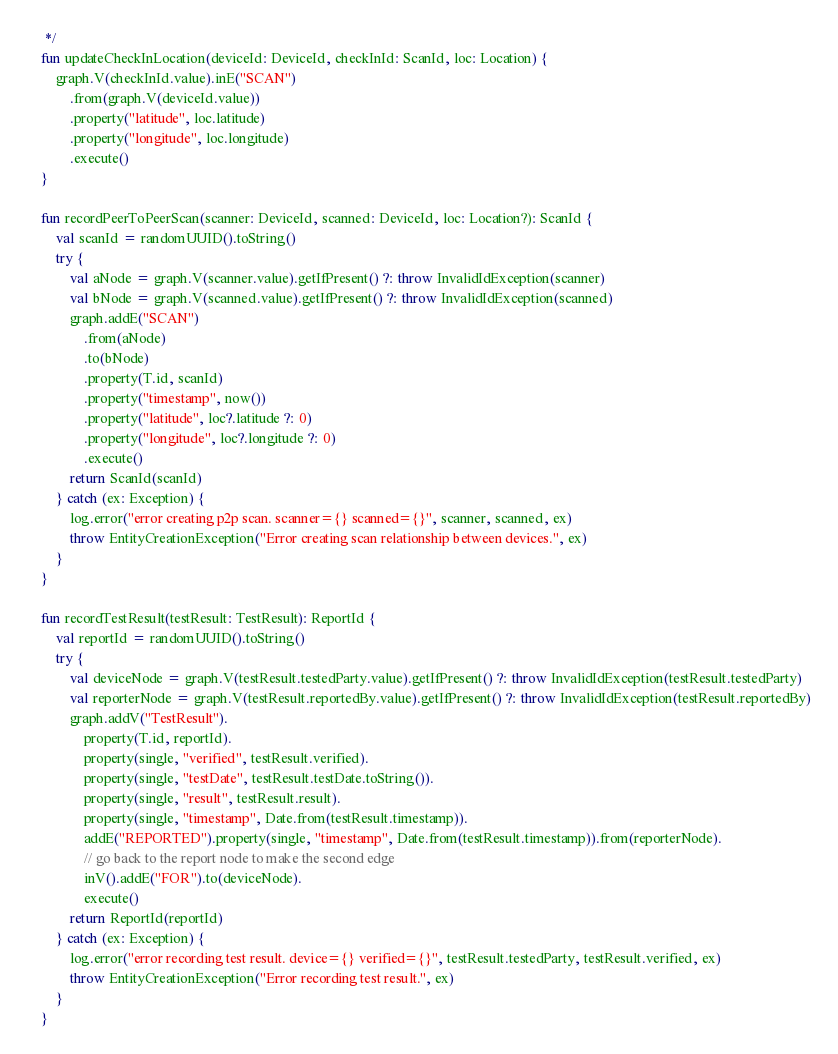<code> <loc_0><loc_0><loc_500><loc_500><_Kotlin_>     */
    fun updateCheckInLocation(deviceId: DeviceId, checkInId: ScanId, loc: Location) {
        graph.V(checkInId.value).inE("SCAN")
            .from(graph.V(deviceId.value))
            .property("latitude", loc.latitude)
            .property("longitude", loc.longitude)
            .execute()
    }

    fun recordPeerToPeerScan(scanner: DeviceId, scanned: DeviceId, loc: Location?): ScanId {
        val scanId = randomUUID().toString()
        try {
            val aNode = graph.V(scanner.value).getIfPresent() ?: throw InvalidIdException(scanner)
            val bNode = graph.V(scanned.value).getIfPresent() ?: throw InvalidIdException(scanned)
            graph.addE("SCAN")
                .from(aNode)
                .to(bNode)
                .property(T.id, scanId)
                .property("timestamp", now())
                .property("latitude", loc?.latitude ?: 0)
                .property("longitude", loc?.longitude ?: 0)
                .execute()
            return ScanId(scanId)
        } catch (ex: Exception) {
            log.error("error creating p2p scan. scanner={} scanned={}", scanner, scanned, ex)
            throw EntityCreationException("Error creating scan relationship between devices.", ex)
        }
    }

    fun recordTestResult(testResult: TestResult): ReportId {
        val reportId = randomUUID().toString()
        try {
            val deviceNode = graph.V(testResult.testedParty.value).getIfPresent() ?: throw InvalidIdException(testResult.testedParty)
            val reporterNode = graph.V(testResult.reportedBy.value).getIfPresent() ?: throw InvalidIdException(testResult.reportedBy)
            graph.addV("TestResult").
                property(T.id, reportId).
                property(single, "verified", testResult.verified).
                property(single, "testDate", testResult.testDate.toString()).
                property(single, "result", testResult.result).
                property(single, "timestamp", Date.from(testResult.timestamp)).
                addE("REPORTED").property(single, "timestamp", Date.from(testResult.timestamp)).from(reporterNode).
                // go back to the report node to make the second edge
                inV().addE("FOR").to(deviceNode).
                execute()
            return ReportId(reportId)
        } catch (ex: Exception) {
            log.error("error recording test result. device={} verified={}", testResult.testedParty, testResult.verified, ex)
            throw EntityCreationException("Error recording test result.", ex)
        }
    }
</code> 